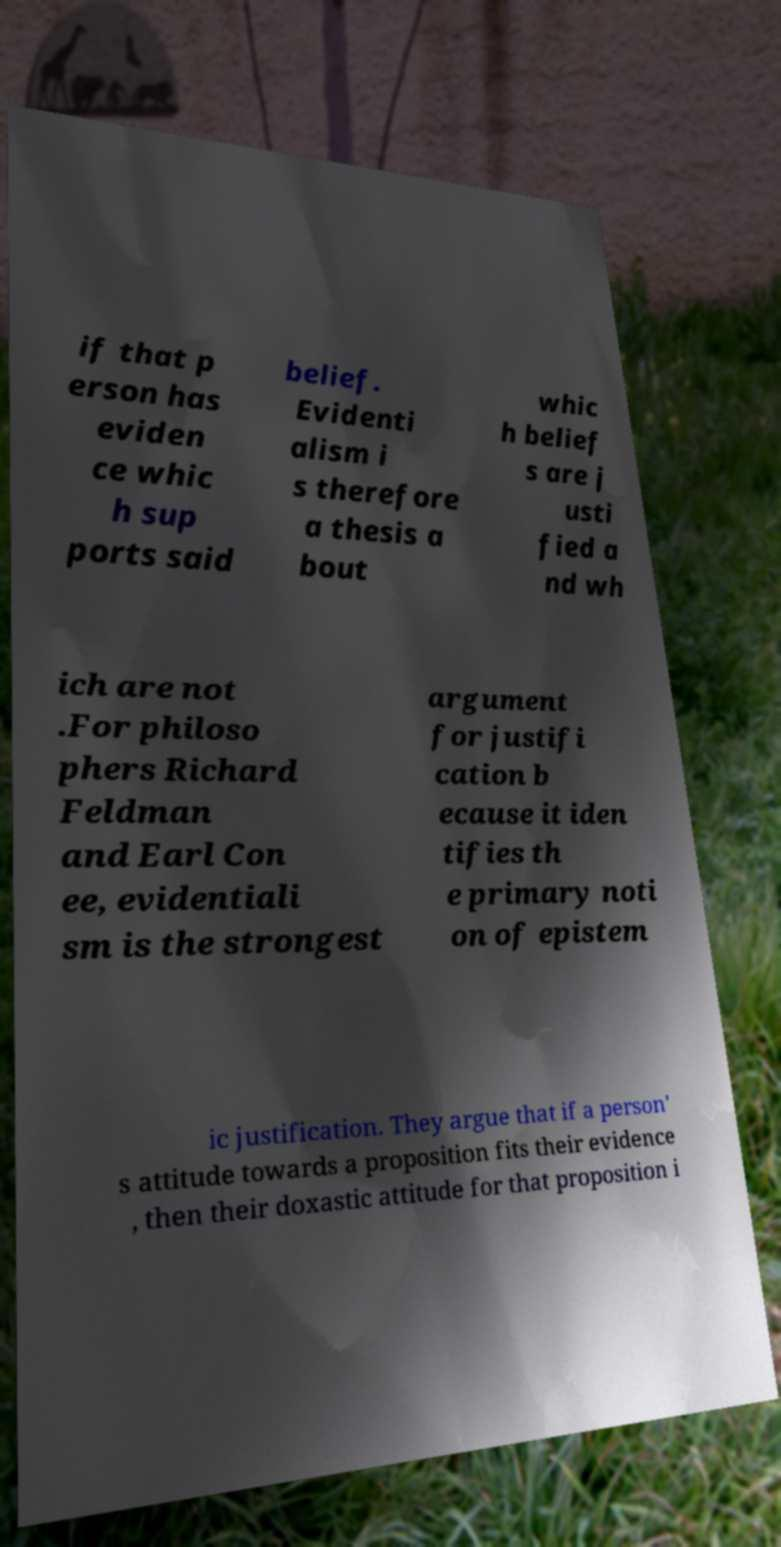There's text embedded in this image that I need extracted. Can you transcribe it verbatim? if that p erson has eviden ce whic h sup ports said belief. Evidenti alism i s therefore a thesis a bout whic h belief s are j usti fied a nd wh ich are not .For philoso phers Richard Feldman and Earl Con ee, evidentiali sm is the strongest argument for justifi cation b ecause it iden tifies th e primary noti on of epistem ic justification. They argue that if a person' s attitude towards a proposition fits their evidence , then their doxastic attitude for that proposition i 